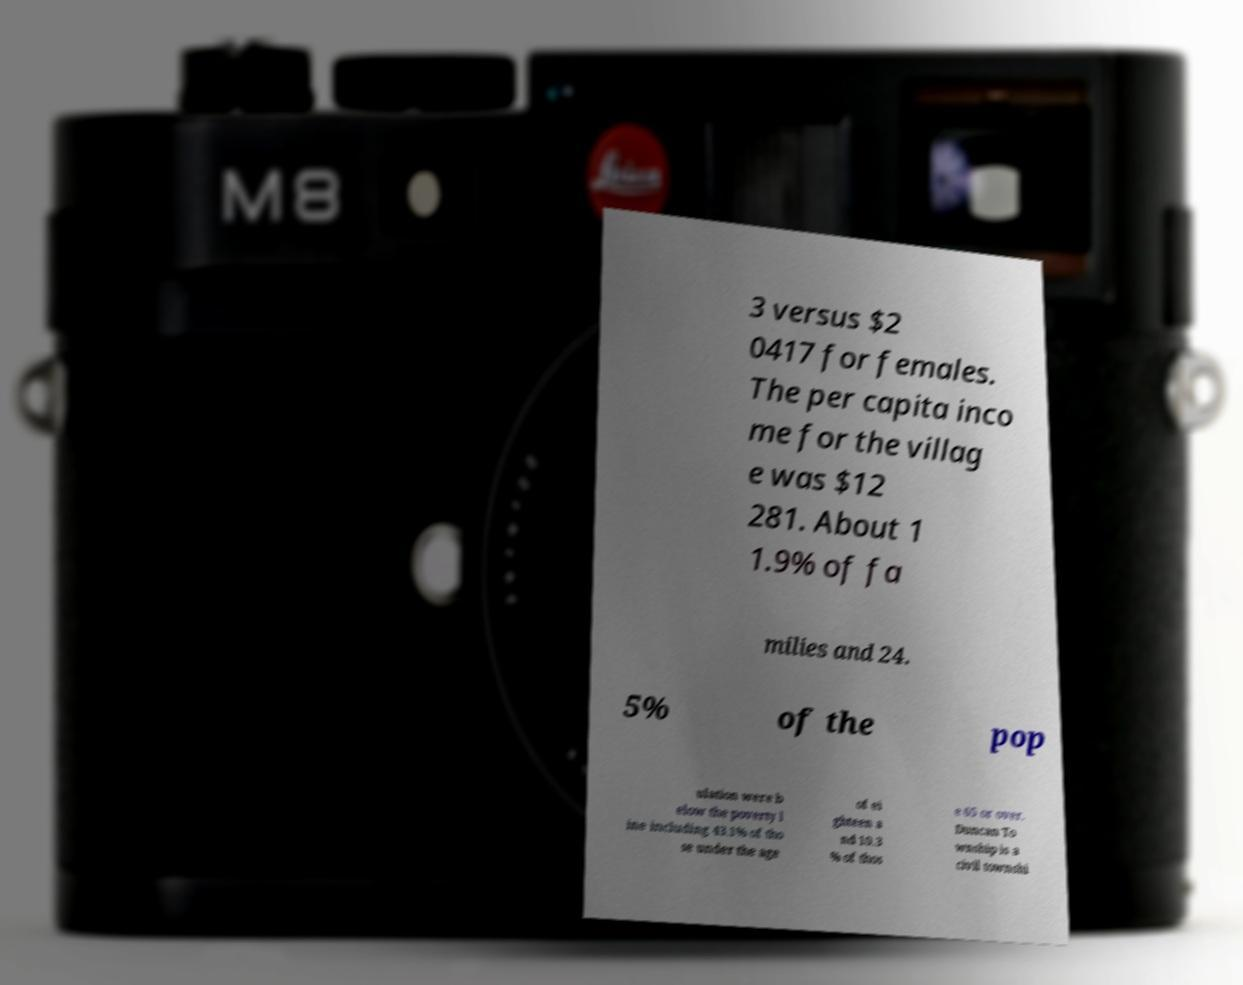What messages or text are displayed in this image? I need them in a readable, typed format. 3 versus $2 0417 for females. The per capita inco me for the villag e was $12 281. About 1 1.9% of fa milies and 24. 5% of the pop ulation were b elow the poverty l ine including 43.1% of tho se under the age of ei ghteen a nd 10.3 % of thos e 65 or over. Duncan To wnship is a civil townshi 